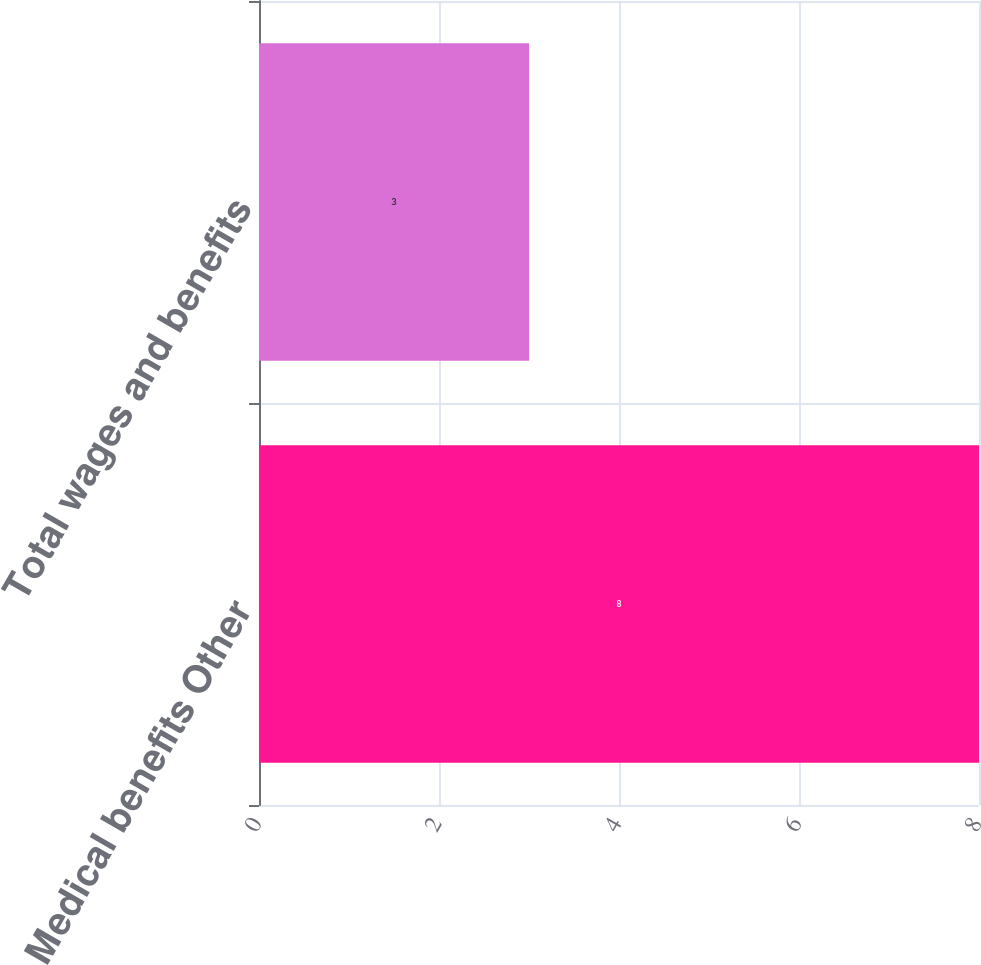Convert chart to OTSL. <chart><loc_0><loc_0><loc_500><loc_500><bar_chart><fcel>Medical benefits Other<fcel>Total wages and benefits<nl><fcel>8<fcel>3<nl></chart> 